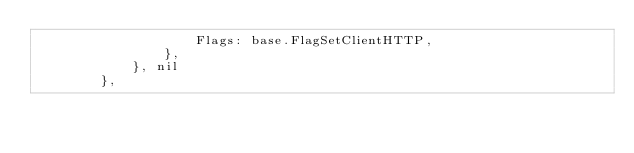<code> <loc_0><loc_0><loc_500><loc_500><_Go_>					Flags: base.FlagSetClientHTTP,
				},
			}, nil
		},
</code> 